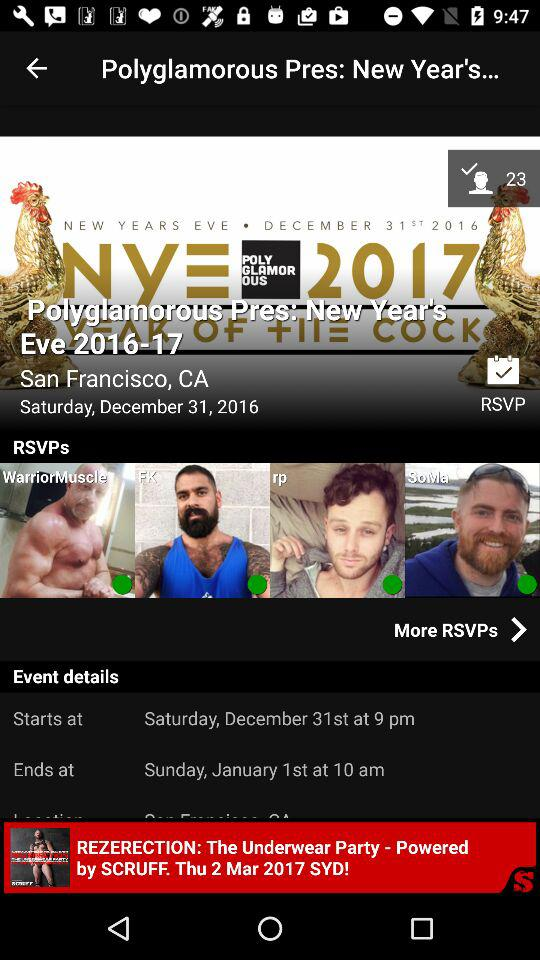Define the age of selected user?
When the provided information is insufficient, respond with <no answer>. <no answer> 